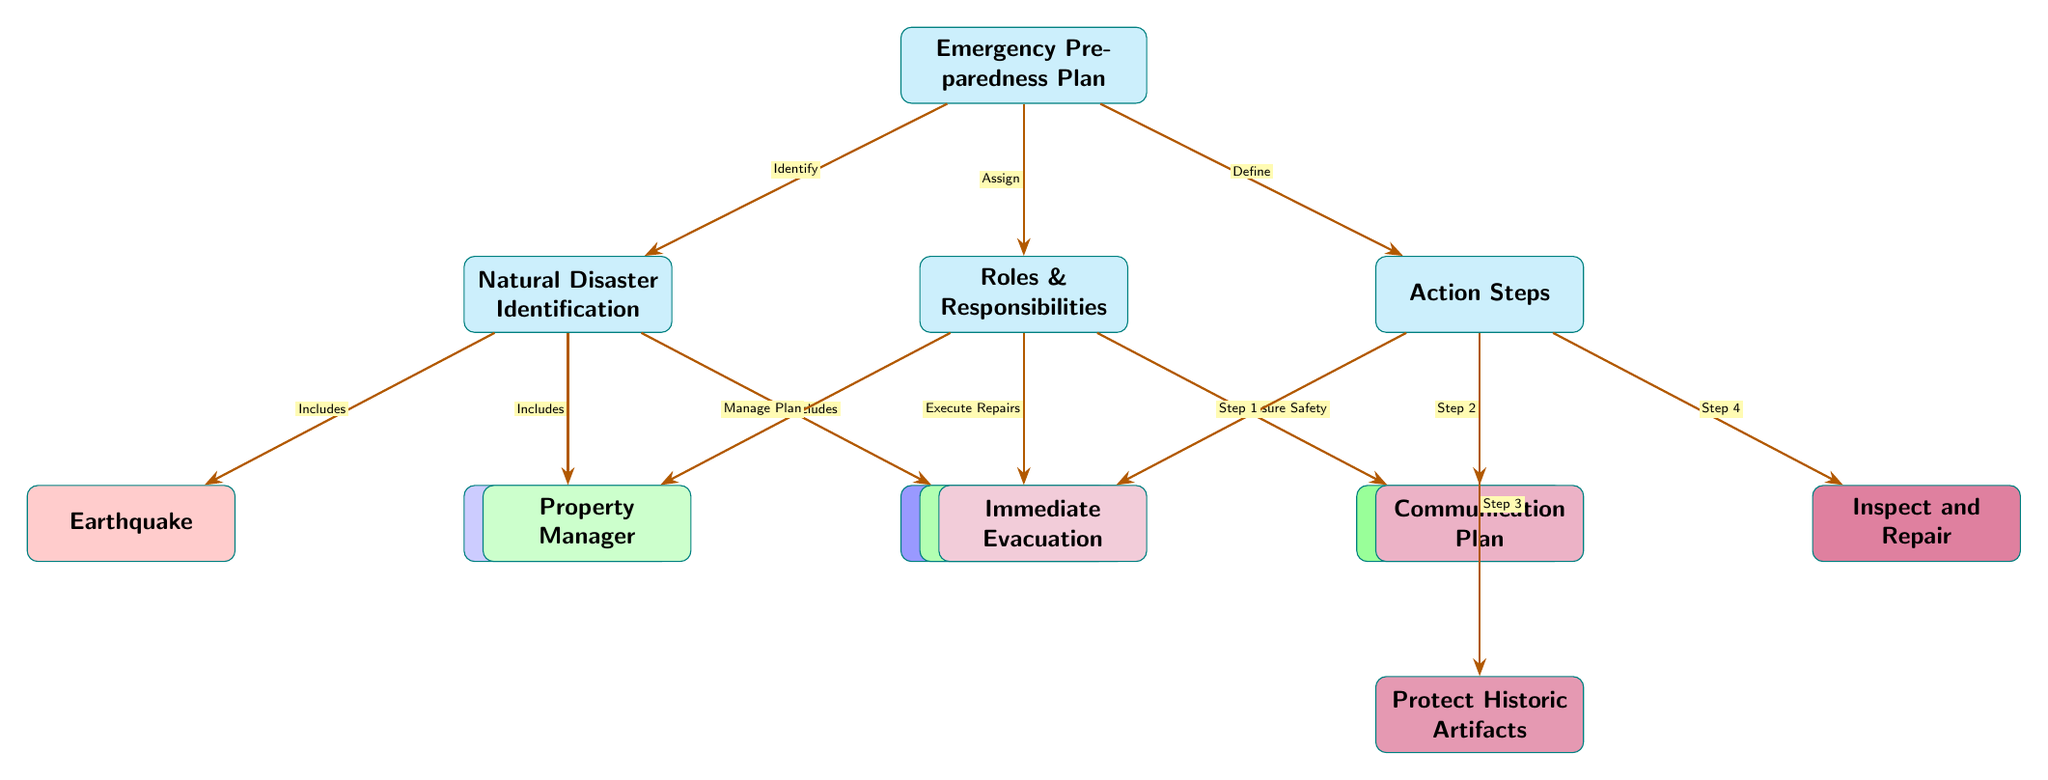What is the main node of the diagram? The main node is labeled "Emergency Preparedness Plan," which serves as the central theme of the diagram.
Answer: Emergency Preparedness Plan How many types of natural disasters are identified? There are three types of natural disasters listed in the diagram: Earthquake, Hurricane, and Flood.
Answer: 3 Who is responsible for managing the plan? The diagram specifies that the Property Manager (PM) is responsible for managing the plan within Roles & Responsibilities.
Answer: Property Manager What is the action step associated with the immediate evacuation? The first action step under Action Steps is labeled "Immediate Evacuation," which indicates it is the first priority during an emergency.
Answer: Immediate Evacuation Which natural disaster is included along with Earthquake? The diagram indicates that both Hurricane and Earthquake are part of the Natural Disaster Identification node.
Answer: Hurricane What does the Security Team ensure? According to the diagram, the Security Team's responsibility is to "Ensure Safety," which is one of the roles identified.
Answer: Ensure Safety What is the last action step listed in the Action Steps section? The diagram presents "Inspect and Repair" as the last action step, indicating it is the final step in the sequence.
Answer: Inspect and Repair Which roles execute repairs? The diagram specifies that Maintenance Staff (MS) is responsible for executing repairs within the Roles & Responsibilities node.
Answer: Maintenance Staff How are the components of the diagram connected? The diagram shows connections between nodes using arrows, indicating the flow of processes like identification, assignment, and action steps effectively.
Answer: Arrows What color represents the Action Steps in the diagram? The Action Steps are represented in a purple color scheme, indicating a distinct category from others.
Answer: Purple 